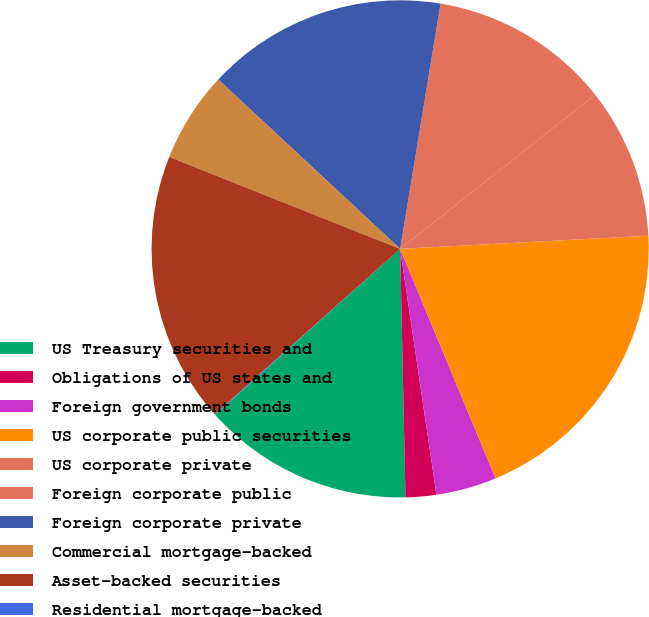Convert chart to OTSL. <chart><loc_0><loc_0><loc_500><loc_500><pie_chart><fcel>US Treasury securities and<fcel>Obligations of US states and<fcel>Foreign government bonds<fcel>US corporate public securities<fcel>US corporate private<fcel>Foreign corporate public<fcel>Foreign corporate private<fcel>Commercial mortgage-backed<fcel>Asset-backed securities<fcel>Residential mortgage-backed<nl><fcel>13.71%<fcel>1.99%<fcel>3.94%<fcel>19.57%<fcel>9.8%<fcel>11.76%<fcel>15.67%<fcel>5.9%<fcel>17.62%<fcel>0.04%<nl></chart> 